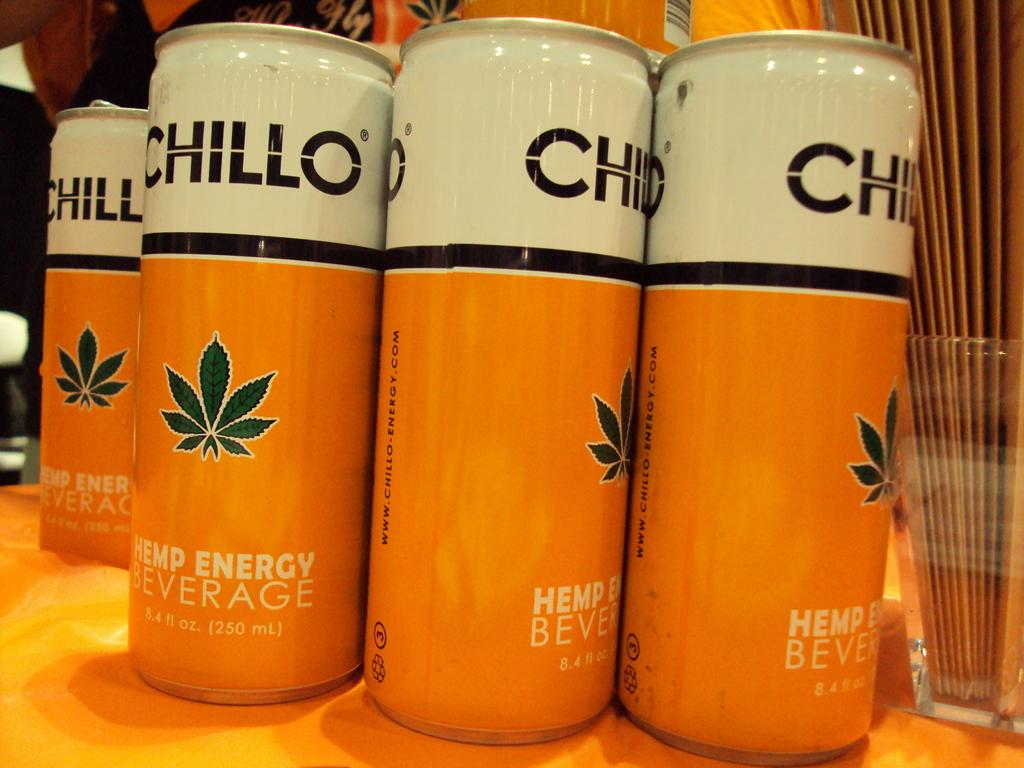What type of corn can be seen growing in the alley in the image? There is no alley or corn present in the image. 